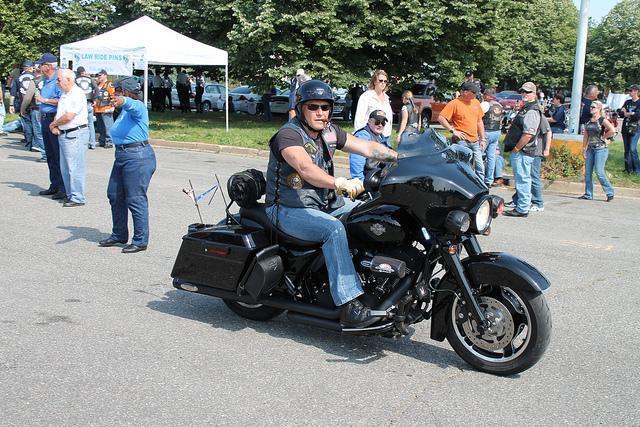What is the man with the helmet on wearing?
Choose the correct response, then elucidate: 'Answer: answer
Rationale: rationale.'
Options: Mask, bowtie, necklace, sunglasses. Answer: sunglasses.
Rationale: The man's eyes are covered. he is not wearing a necklace, mask, or bowtie. 